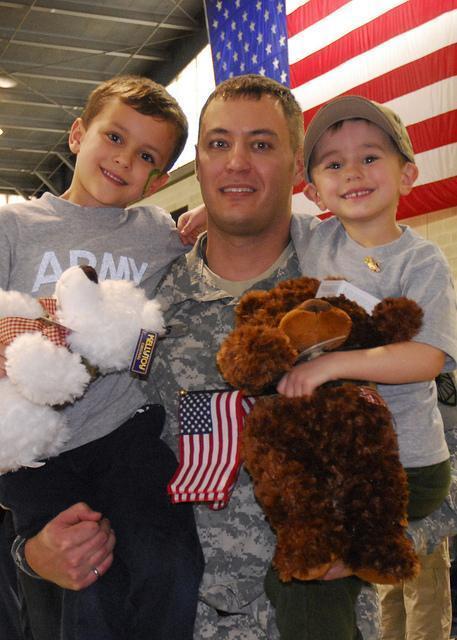How many people can be seen?
Give a very brief answer. 3. How many teddy bears are there?
Give a very brief answer. 2. How many birds have red on their head?
Give a very brief answer. 0. 